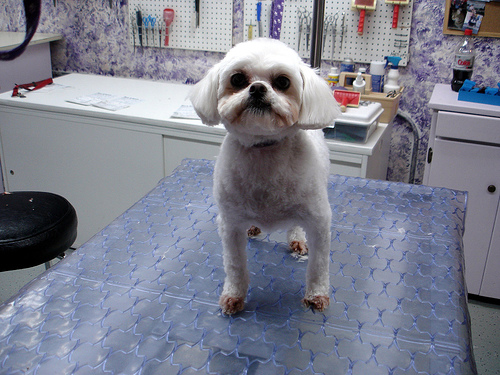<image>
Is there a dog on the seat? No. The dog is not positioned on the seat. They may be near each other, but the dog is not supported by or resting on top of the seat. Where is the table in relation to the dog? Is it behind the dog? No. The table is not behind the dog. From this viewpoint, the table appears to be positioned elsewhere in the scene. Where is the dog in relation to the stool? Is it in front of the stool? Yes. The dog is positioned in front of the stool, appearing closer to the camera viewpoint. 